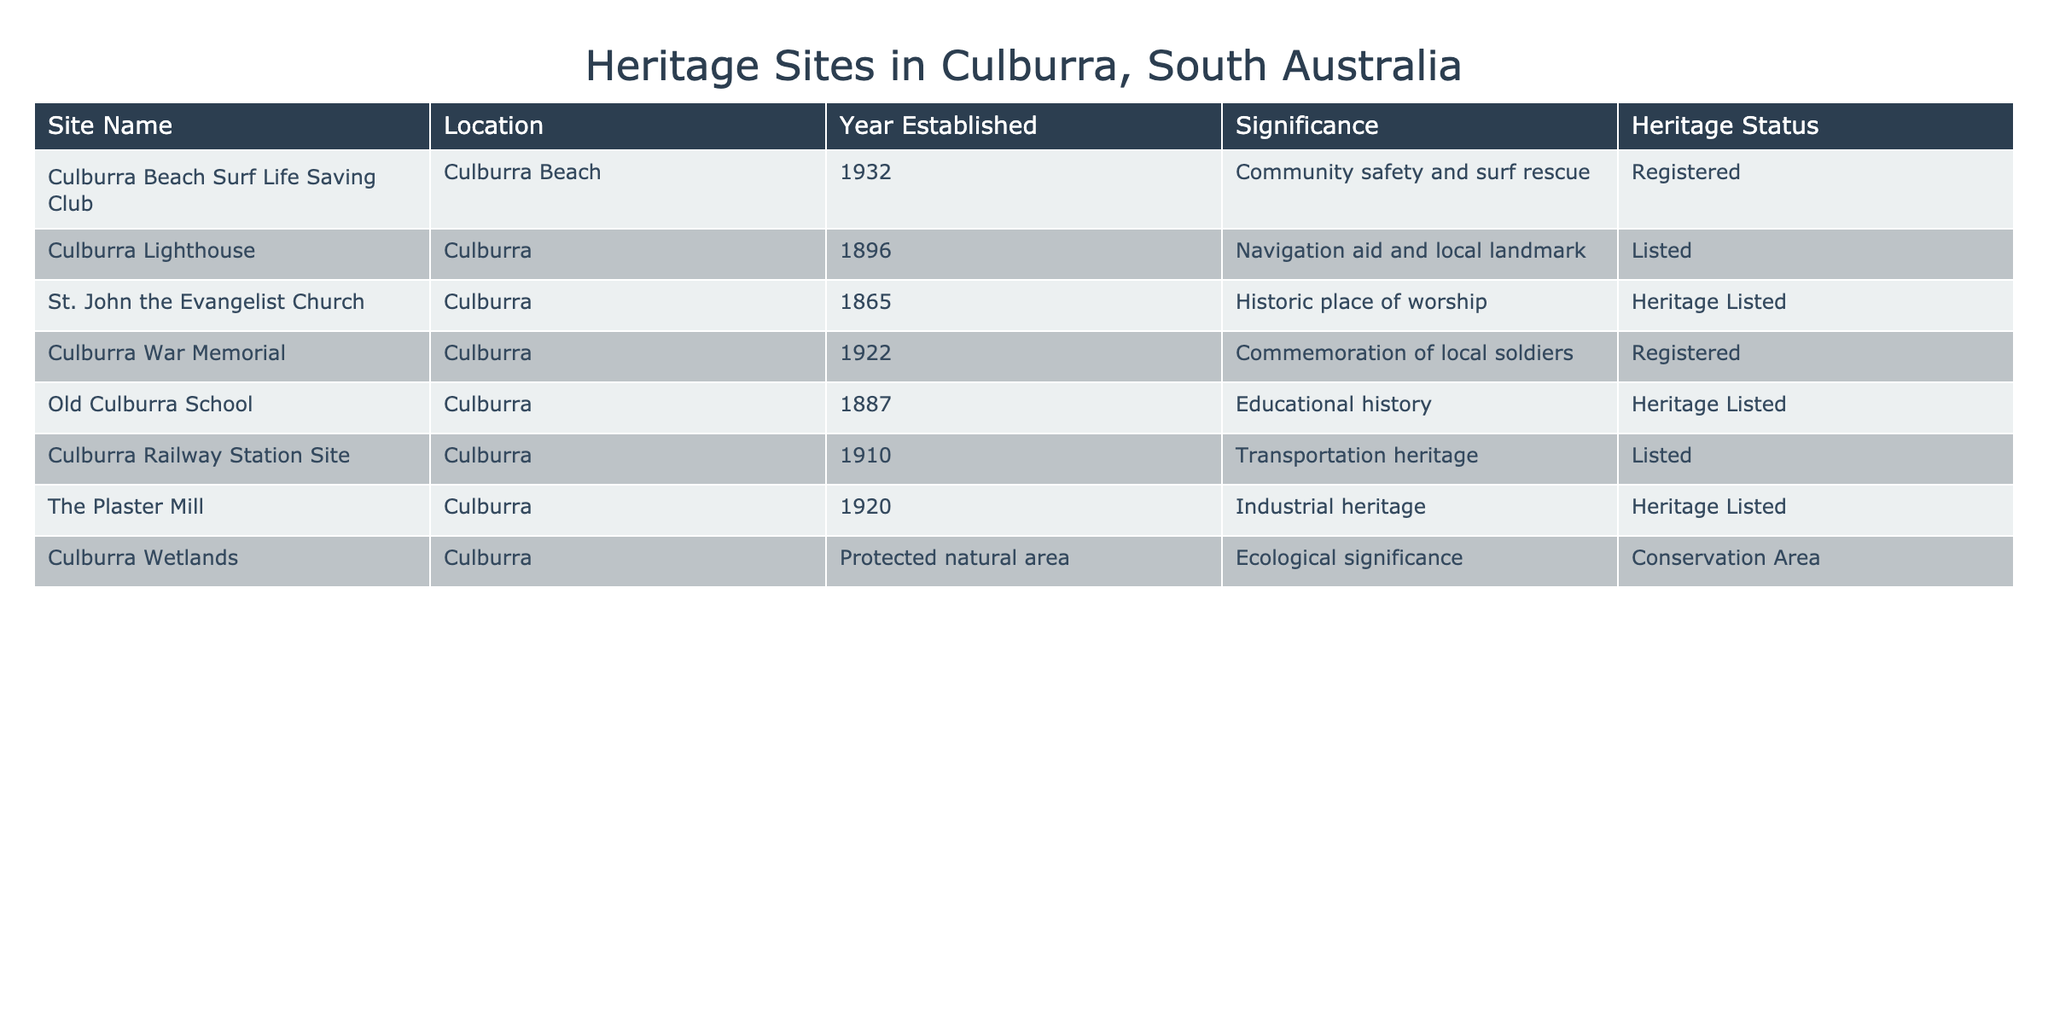What is the significance of the Culburra Lighthouse? The table indicates that the significance of the Culburra Lighthouse is as a navigation aid and local landmark.
Answer: Navigation aid and local landmark How many heritage sites were established before 1900? By examining the 'Year Established' column, the relevant sites are St. John the Evangelist Church (1865) and Culburra Lighthouse (1896). This gives us a total of 2 heritage sites.
Answer: 2 Is the Culburra Railway Station Site Heritage Listed? The table shows that the Culburra Railway Station Site is listed as 'Listed', not as 'Heritage Listed', indicating it is not classified with the same heritage status.
Answer: No What is the total number of sites registered for community significance? To find this, we look at the 'Heritage Status' for registered sites with community significance. From the table, the Culburra Beach Surf Life Saving Club and the Culburra War Memorial are both registered, summing up to 2 sites.
Answer: 2 Which heritage site has the most recent establishment year, and what is its significance? The most recent establishment year is 1932, which corresponds to the Culburra Beach Surf Life Saving Club. Its significance is community safety and surf rescue.
Answer: Culburra Beach Surf Life Saving Club; community safety and surf rescue Are there more sites with ecological significance or educational history? The table lists one ecological site (Culburra Wetlands) and one educational site (Old Culburra School). Therefore, they are equal in number.
Answer: They are equal Which site has a designation of 'Conservation Area'? From the table, the Culburra Wetlands is the site designated as a 'Conservation Area', emphasizing its ecological significance.
Answer: Culburra Wetlands What percentage of the listed sites are also registered? There are 8 sites listed in total. Among these, the registered sites are the Culburra Beach Surf Life Saving Club and the Culburra War Memorial, totaling 2 registered sites. The percentage is (2 registered / 8 total) * 100 = 25%.
Answer: 25% 